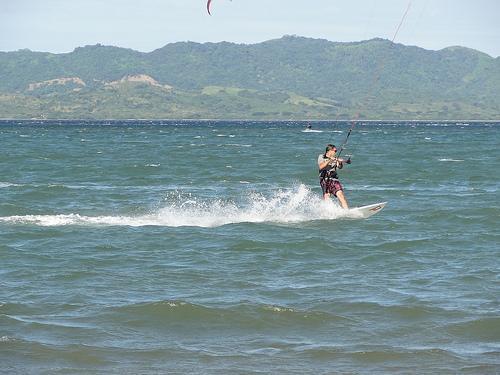How many people?
Give a very brief answer. 2. 